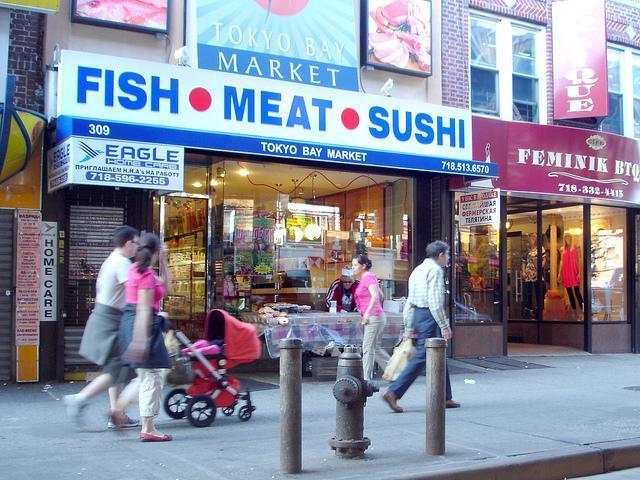How many people are wearing pink shirts?
Give a very brief answer. 2. How many people can you see?
Give a very brief answer. 4. How many bananas are visible?
Give a very brief answer. 0. 